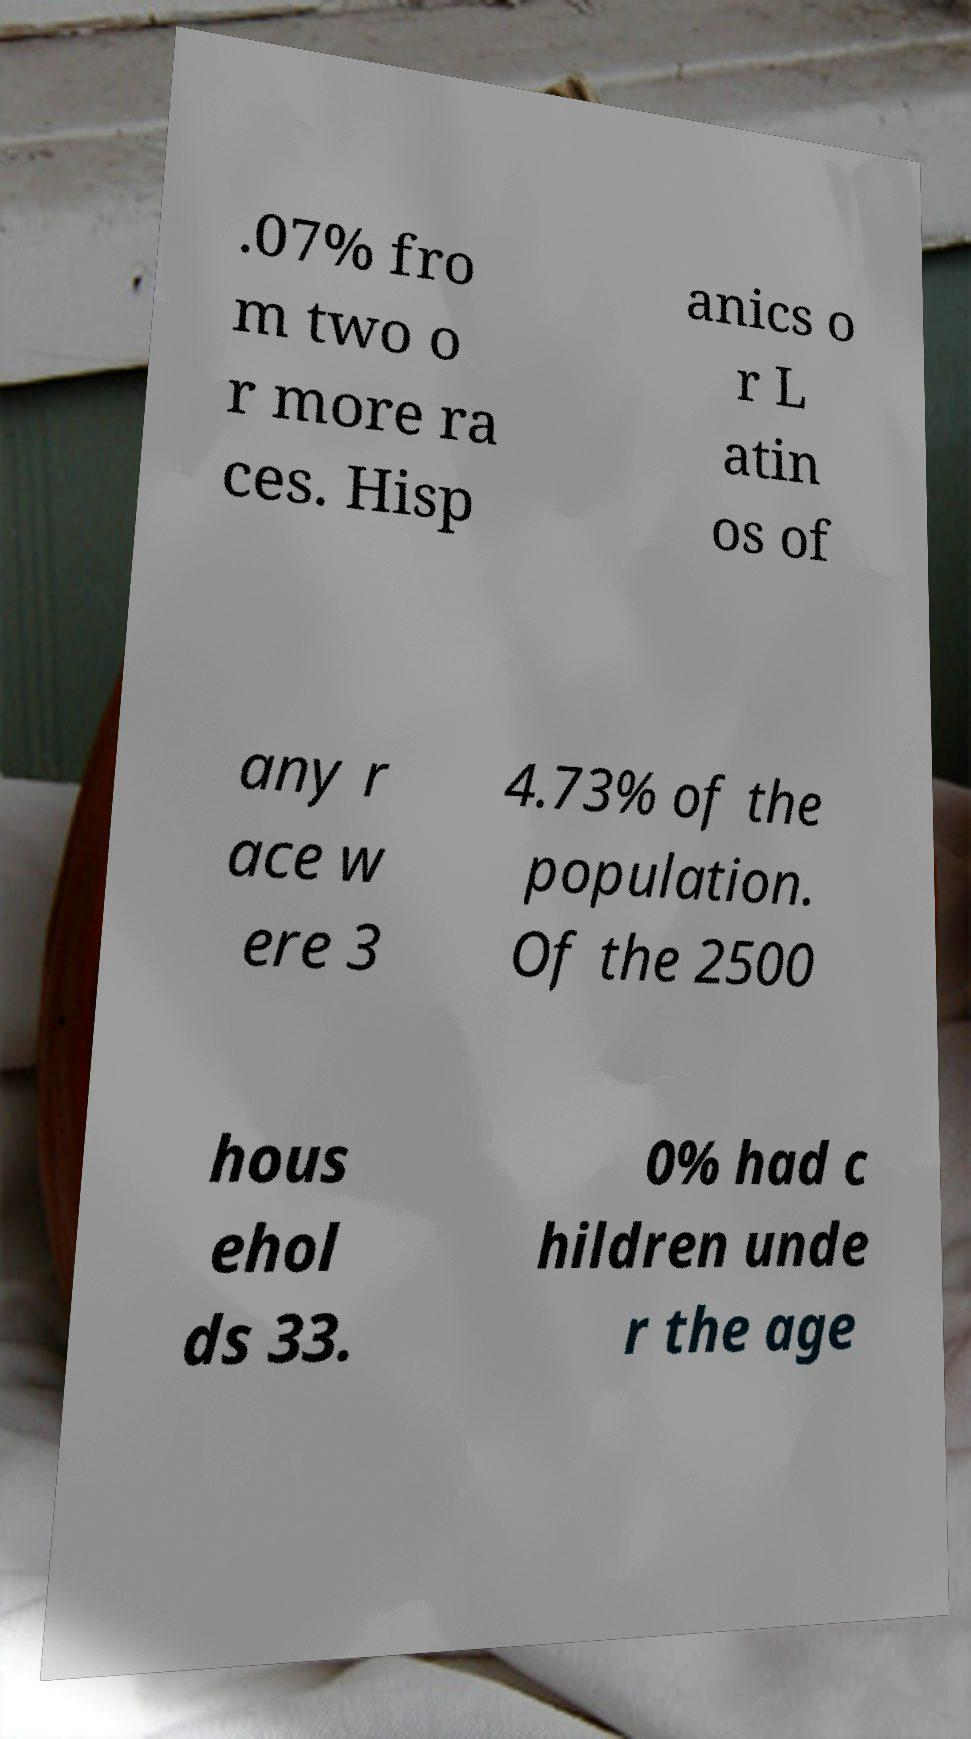For documentation purposes, I need the text within this image transcribed. Could you provide that? .07% fro m two o r more ra ces. Hisp anics o r L atin os of any r ace w ere 3 4.73% of the population. Of the 2500 hous ehol ds 33. 0% had c hildren unde r the age 